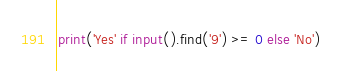<code> <loc_0><loc_0><loc_500><loc_500><_Python_>print('Yes' if input().find('9') >= 0 else 'No')
</code> 